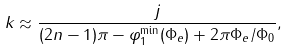<formula> <loc_0><loc_0><loc_500><loc_500>k \approx \frac { j } { ( 2 n - 1 ) \pi - \varphi _ { 1 } ^ { \min } ( \Phi _ { e } ) + 2 \pi \Phi _ { e } / \Phi _ { 0 } } ,</formula> 